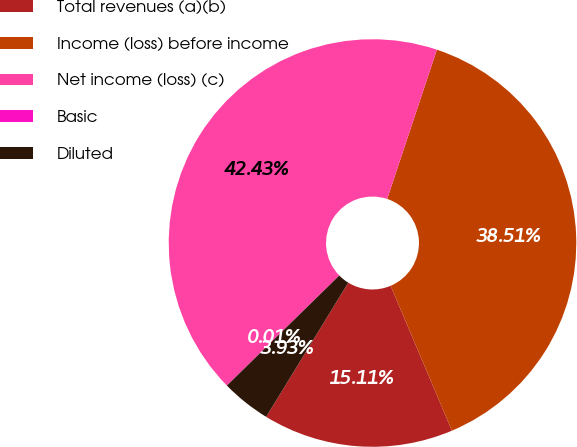<chart> <loc_0><loc_0><loc_500><loc_500><pie_chart><fcel>Total revenues (a)(b)<fcel>Income (loss) before income<fcel>Net income (loss) (c)<fcel>Basic<fcel>Diluted<nl><fcel>15.11%<fcel>38.51%<fcel>42.43%<fcel>0.01%<fcel>3.93%<nl></chart> 